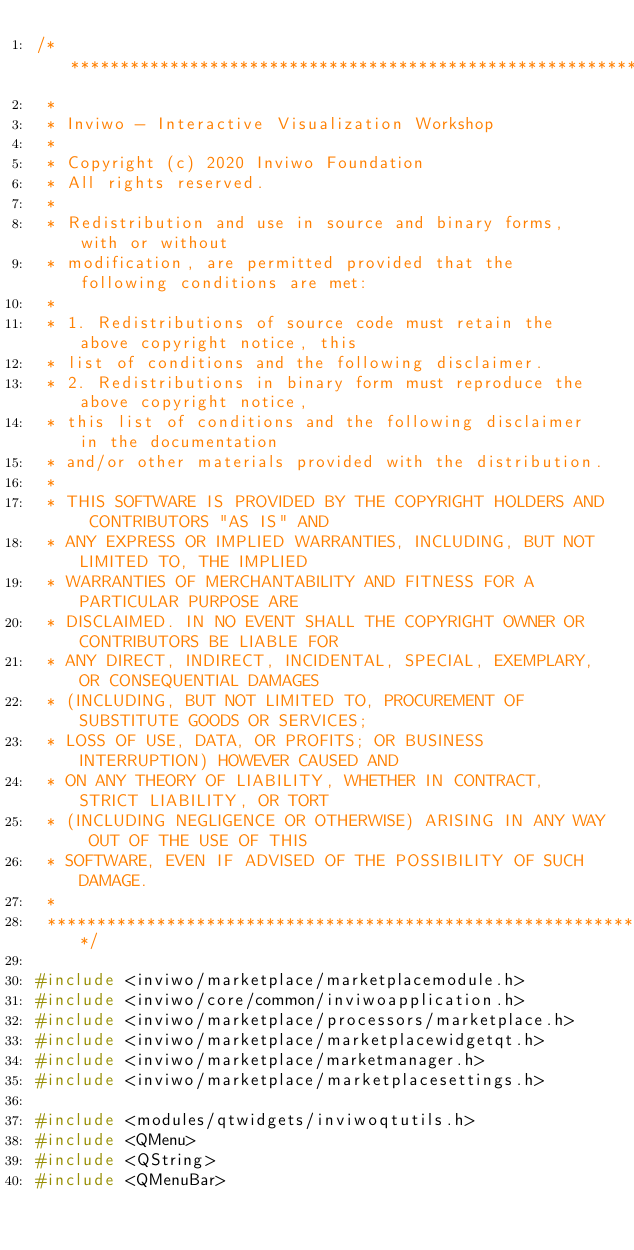<code> <loc_0><loc_0><loc_500><loc_500><_C++_>/*********************************************************************************
 *
 * Inviwo - Interactive Visualization Workshop
 *
 * Copyright (c) 2020 Inviwo Foundation
 * All rights reserved.
 *
 * Redistribution and use in source and binary forms, with or without
 * modification, are permitted provided that the following conditions are met:
 *
 * 1. Redistributions of source code must retain the above copyright notice, this
 * list of conditions and the following disclaimer.
 * 2. Redistributions in binary form must reproduce the above copyright notice,
 * this list of conditions and the following disclaimer in the documentation
 * and/or other materials provided with the distribution.
 *
 * THIS SOFTWARE IS PROVIDED BY THE COPYRIGHT HOLDERS AND CONTRIBUTORS "AS IS" AND
 * ANY EXPRESS OR IMPLIED WARRANTIES, INCLUDING, BUT NOT LIMITED TO, THE IMPLIED
 * WARRANTIES OF MERCHANTABILITY AND FITNESS FOR A PARTICULAR PURPOSE ARE
 * DISCLAIMED. IN NO EVENT SHALL THE COPYRIGHT OWNER OR CONTRIBUTORS BE LIABLE FOR
 * ANY DIRECT, INDIRECT, INCIDENTAL, SPECIAL, EXEMPLARY, OR CONSEQUENTIAL DAMAGES
 * (INCLUDING, BUT NOT LIMITED TO, PROCUREMENT OF SUBSTITUTE GOODS OR SERVICES;
 * LOSS OF USE, DATA, OR PROFITS; OR BUSINESS INTERRUPTION) HOWEVER CAUSED AND
 * ON ANY THEORY OF LIABILITY, WHETHER IN CONTRACT, STRICT LIABILITY, OR TORT
 * (INCLUDING NEGLIGENCE OR OTHERWISE) ARISING IN ANY WAY OUT OF THE USE OF THIS
 * SOFTWARE, EVEN IF ADVISED OF THE POSSIBILITY OF SUCH DAMAGE.
 *
 *********************************************************************************/

#include <inviwo/marketplace/marketplacemodule.h>
#include <inviwo/core/common/inviwoapplication.h>
#include <inviwo/marketplace/processors/marketplace.h>
#include <inviwo/marketplace/marketplacewidgetqt.h>
#include <inviwo/marketplace/marketmanager.h>
#include <inviwo/marketplace/marketplacesettings.h>

#include <modules/qtwidgets/inviwoqtutils.h>
#include <QMenu>
#include <QString>
#include <QMenuBar></code> 